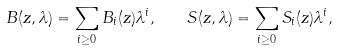Convert formula to latex. <formula><loc_0><loc_0><loc_500><loc_500>B ( z , \lambda ) = \sum _ { i \geq 0 } B _ { i } ( z ) \lambda ^ { i } , \quad S ( z , \lambda ) = \sum _ { i \geq 0 } S _ { i } ( z ) \lambda ^ { i } ,</formula> 